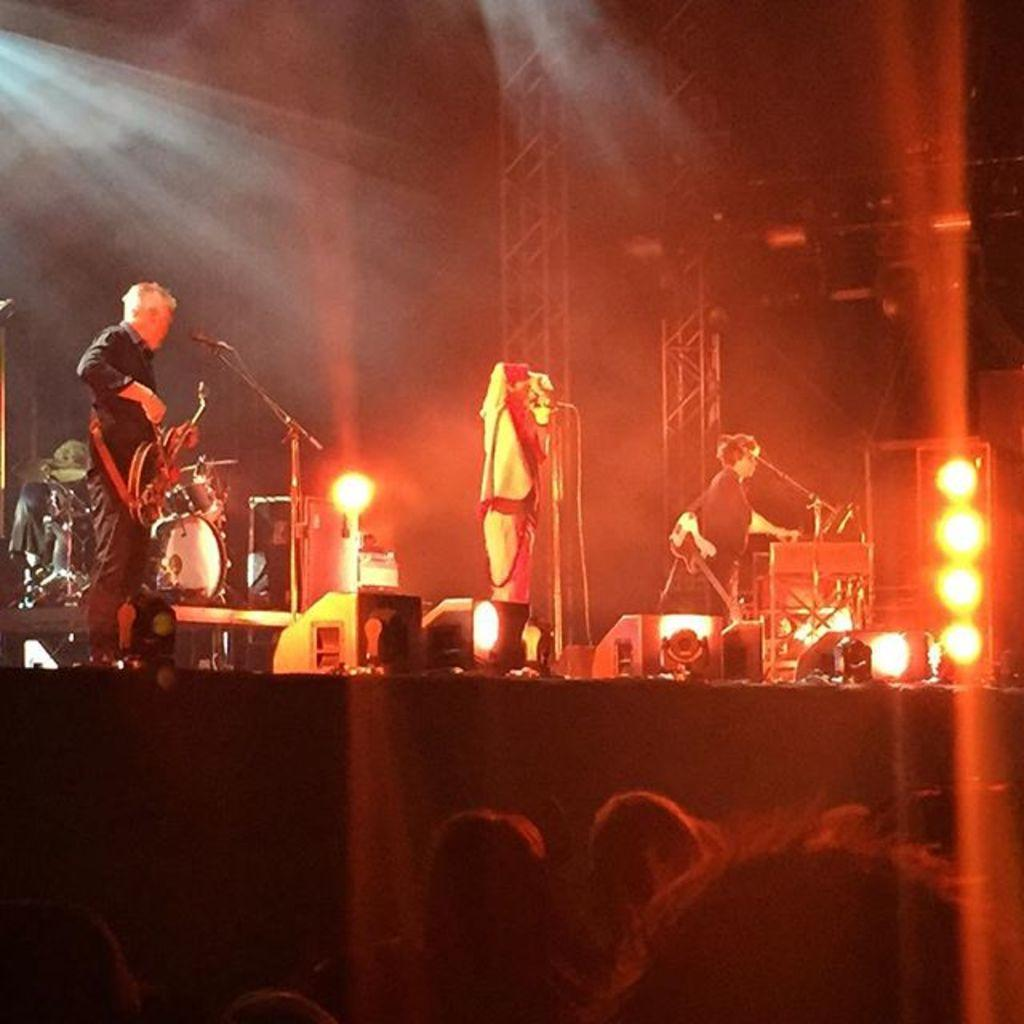What are the four people on stage doing? They are performing, playing a guitar, and singing on a microphone. What might the audience be doing while the performers are on stage? The audience is likely watching and listening to the performers. What type of care can be seen being administered to the airplane in the image? There is no airplane present in the image, and therefore no care being administered to it. What type of shock is visible on the performers' faces in the image? There is no indication of shock on the performers' faces in the image. 